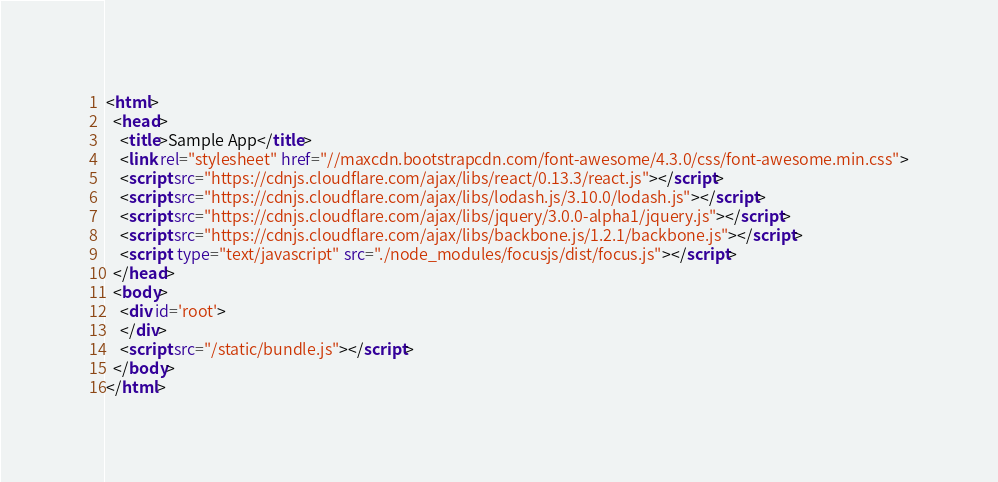Convert code to text. <code><loc_0><loc_0><loc_500><loc_500><_HTML_><html>
  <head>
    <title>Sample App</title>
    <link rel="stylesheet" href="//maxcdn.bootstrapcdn.com/font-awesome/4.3.0/css/font-awesome.min.css">
    <script src="https://cdnjs.cloudflare.com/ajax/libs/react/0.13.3/react.js"></script>
    <script src="https://cdnjs.cloudflare.com/ajax/libs/lodash.js/3.10.0/lodash.js"></script>
    <script src="https://cdnjs.cloudflare.com/ajax/libs/jquery/3.0.0-alpha1/jquery.js"></script>
    <script src="https://cdnjs.cloudflare.com/ajax/libs/backbone.js/1.2.1/backbone.js"></script>
    <script  type="text/javascript" src="./node_modules/focusjs/dist/focus.js"></script>
  </head>
  <body>
    <div id='root'>
    </div>
    <script src="/static/bundle.js"></script>
  </body>
</html>
</code> 